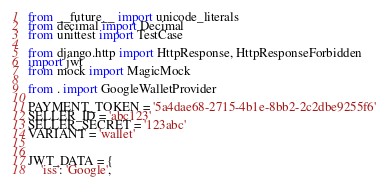Convert code to text. <code><loc_0><loc_0><loc_500><loc_500><_Python_>from __future__ import unicode_literals
from decimal import Decimal
from unittest import TestCase

from django.http import HttpResponse, HttpResponseForbidden
import jwt
from mock import MagicMock

from . import GoogleWalletProvider

PAYMENT_TOKEN = '5a4dae68-2715-4b1e-8bb2-2c2dbe9255f6'
SELLER_ID = 'abc123'
SELLER_SECRET = '123abc'
VARIANT = 'wallet'


JWT_DATA = {
    'iss': 'Google',</code> 